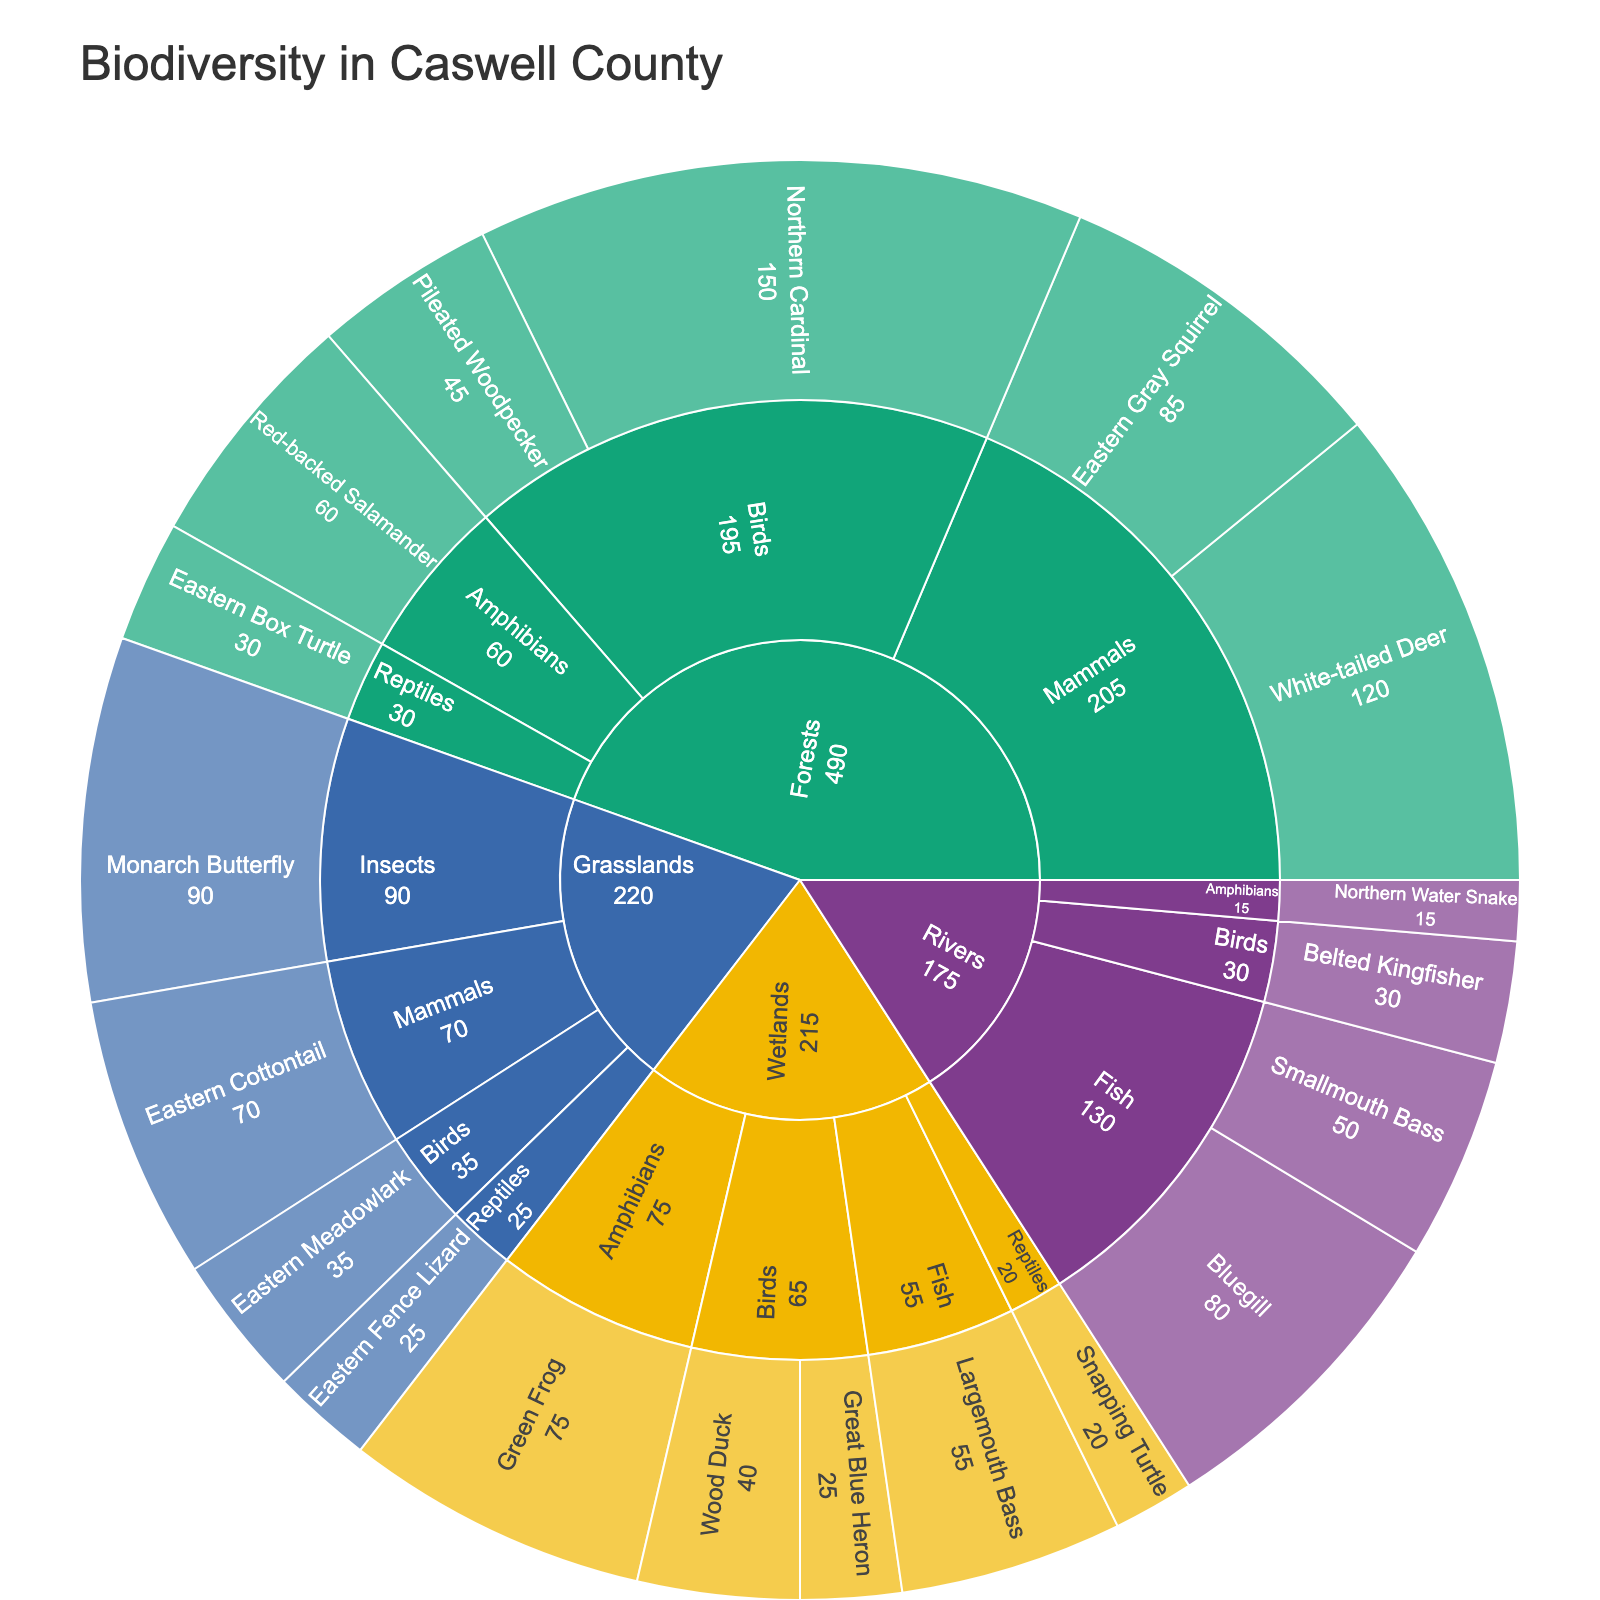What's the most populous species in the 'Forests' habitat? First, look at the 'Forests' habitat section of the plot. Within 'Forests', check the counts for each species. The Northern Cardinal has the highest count of 150.
Answer: Northern Cardinal Which habitat has the highest number of species? Determine the total number of species within each habitat. Forests have the following species: White-tailed Deer, Eastern Gray Squirrel, Northern Cardinal, Pileated Woodpecker, Eastern Box Turtle, Red-backed Salamander. That’s 6 species. Check other habitats similarly to see that none exceed 6 species.
Answer: Forests Compare the 'Amphibians' population between 'Forests' and 'Wetlands'. Which has more and by how much? Look at the counts for Amphibians in both habitats. In Forests, the Red-backed Salamander has 60. In Wetlands, the Green Frog has 75. Taking the difference, 75 - 60 = 15.
Answer: Wetlands, by 15 How many species are tracked in the 'Rivers' habitat? Inspect the number of species listed under the 'Rivers' habitat. The species listed are Bluegill, Smallmouth Bass, Northern Water Snake, and Belted Kingfisher. That’s a total of 4 species.
Answer: 4 In the 'Grasslands' habitat, which taxonomic group appears most frequently? Examine the Grasslands habitat and count the number of appearances of each taxonomic group. The taxonomic groups are Mammals, Birds, Reptiles, and Insects. Each one appears once, so all groups appear equally.
Answer: Equally What's the total count of Mammals across all habitats? Sum the counts of Mammals across all habitats. The counts are 120 (White-tailed Deer), 85 (Eastern Gray Squirrel), and 70 (Eastern Cottontail). 120 + 85 + 70 = 275.
Answer: 275 Which habitat has the fewest documented species and what are they? Compare the species count for each habitat. Wetlands have the least number of documented species after investigation: Great Blue Heron, Wood Duck, Green Frog, Snapping Turtle, Largemouth Bass. That's a total of 5 species. Similarly, Rivers have the least number of species too with 4 species: Bluegill, Smallmouth Bass, Northern Water Snake, Belted Kingfisher.
Answer: Rivers How do the counts of 'Birds'in 'Wetlands' compare with 'Rivers'? Check counts of birds in Wetlands: Great Blue Heron (25), Wood Duck (40). Total in Wetlands is 25 + 40 = 65. For Rivers: Belted Kingfisher (30). Total in Rivers is 30. Compare these totals to see 65 - 30 = 35.
Answer: Wetlands have 35 more 